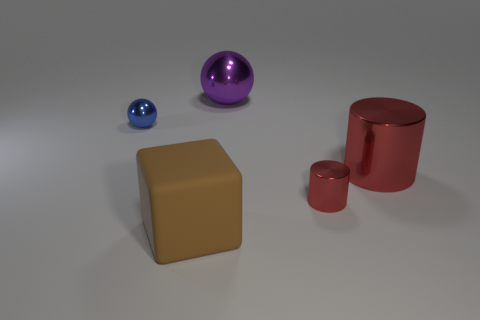What is the size of the other metal cylinder that is the same color as the big cylinder?
Your response must be concise. Small. How big is the brown thing?
Ensure brevity in your answer.  Large. The large purple shiny thing has what shape?
Make the answer very short. Sphere. Is the shape of the blue shiny thing the same as the small metal object that is on the right side of the purple object?
Offer a terse response. No. Does the small object that is in front of the small blue shiny object have the same shape as the big red object?
Offer a very short reply. Yes. How many shiny things are left of the large metal cylinder and in front of the small shiny sphere?
Make the answer very short. 1. What number of other things are the same size as the matte cube?
Your answer should be compact. 2. Are there an equal number of small blue metal spheres that are to the right of the small red cylinder and large gray shiny cylinders?
Provide a short and direct response. Yes. Is the color of the large thing that is right of the purple metal object the same as the metal object in front of the large cylinder?
Your response must be concise. Yes. What is the material of the thing that is on the left side of the large purple ball and in front of the big red thing?
Offer a terse response. Rubber. 